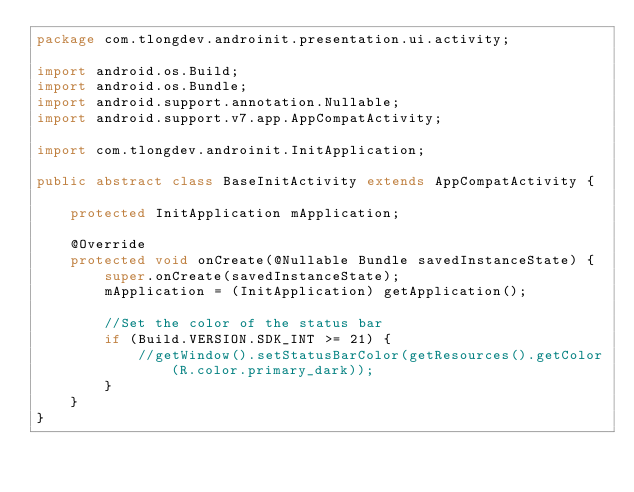Convert code to text. <code><loc_0><loc_0><loc_500><loc_500><_Java_>package com.tlongdev.androinit.presentation.ui.activity;

import android.os.Build;
import android.os.Bundle;
import android.support.annotation.Nullable;
import android.support.v7.app.AppCompatActivity;

import com.tlongdev.androinit.InitApplication;

public abstract class BaseInitActivity extends AppCompatActivity {

    protected InitApplication mApplication;

    @Override
    protected void onCreate(@Nullable Bundle savedInstanceState) {
        super.onCreate(savedInstanceState);
        mApplication = (InitApplication) getApplication();

        //Set the color of the status bar
        if (Build.VERSION.SDK_INT >= 21) {
            //getWindow().setStatusBarColor(getResources().getColor(R.color.primary_dark));
        }
    }
}
</code> 